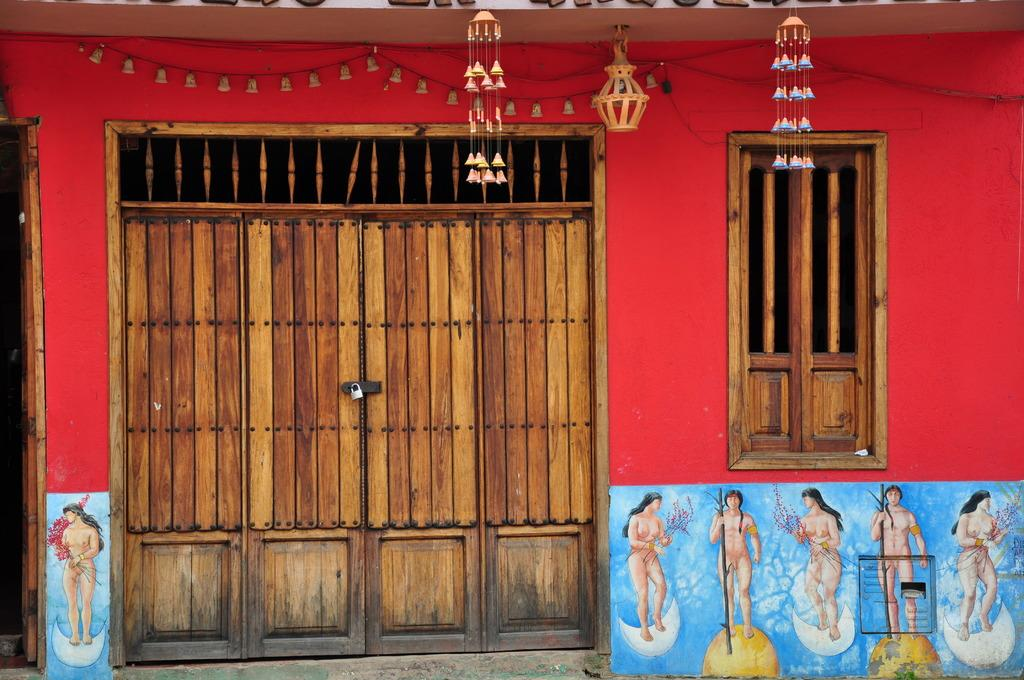What is one of the main features of the picture? There is a door in the picture. Can you describe the door in more detail? The door has a lock and is made of wood. What else can be seen in the picture besides the door? There are pictures of women standing in the picture, and there are bells arranged on the wall. Where is the basket of apples located in the picture? There is no basket of apples present in the image. Can you tell me how many donkeys are sleeping in the picture? There are no donkeys or sleeping animals depicted in the image. 